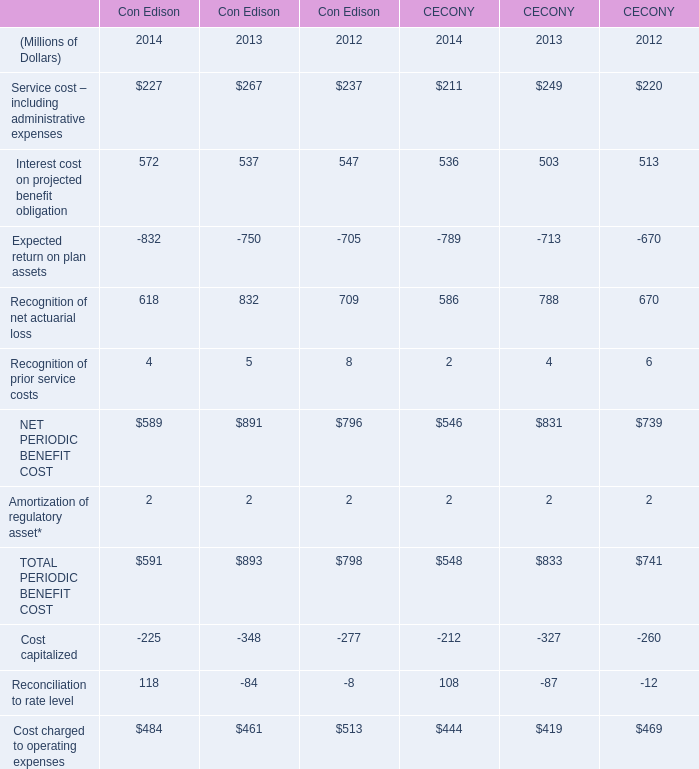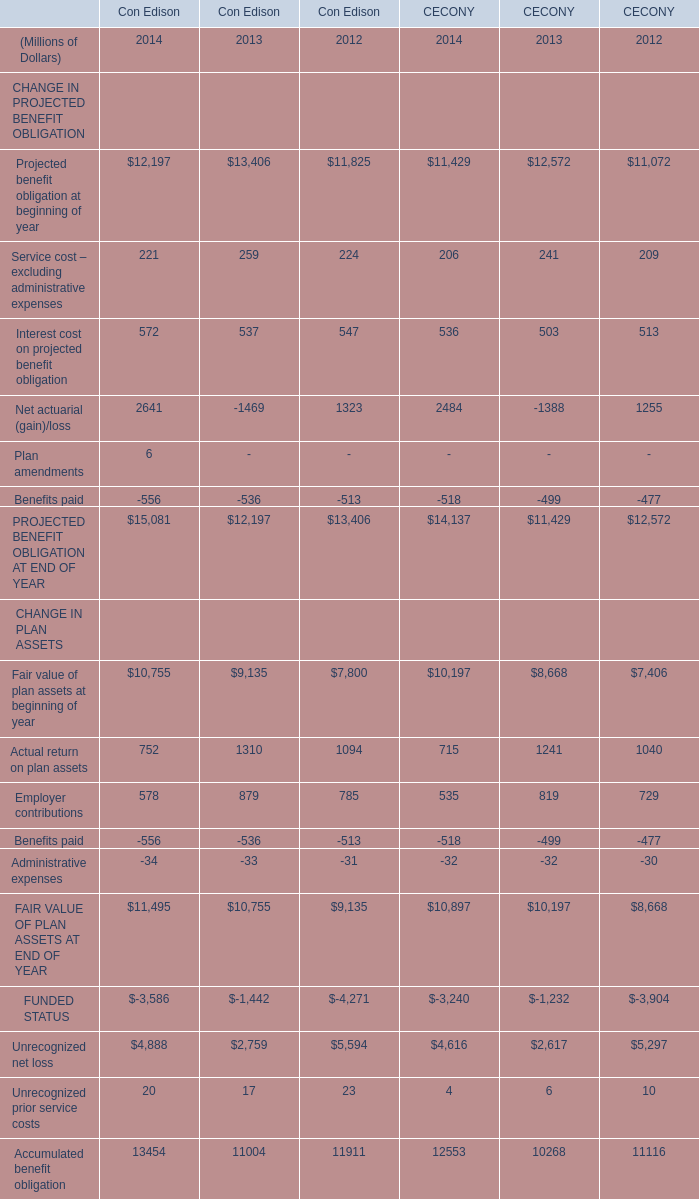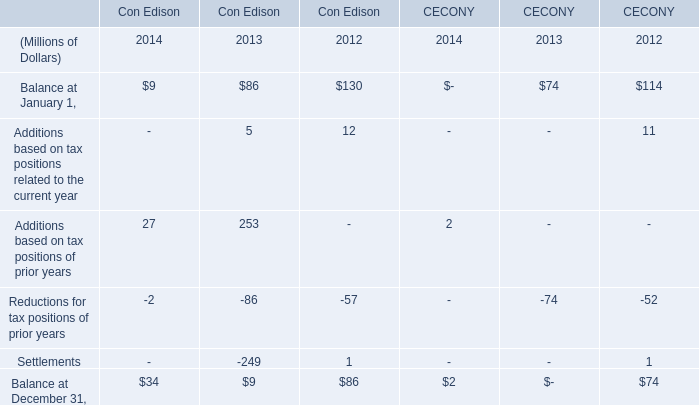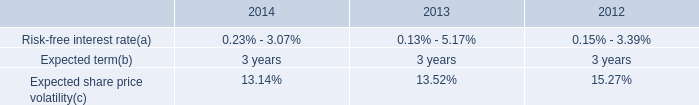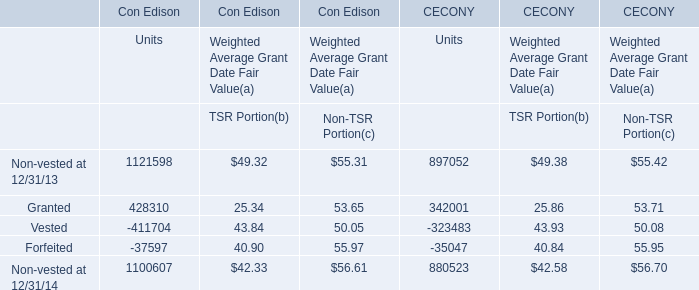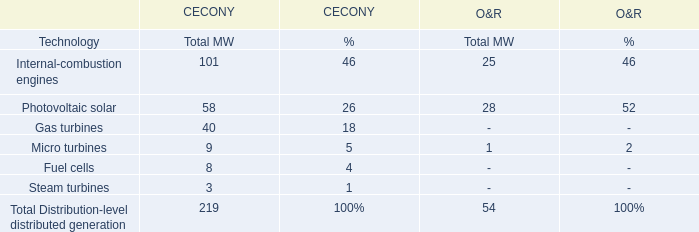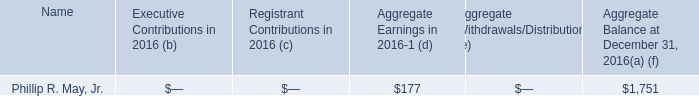what's the total amount of Projected benefit obligation at beginning of year of CECONY 2014, and Forfeited of Con Edison Units ? 
Computations: (11429.0 + 37597.0)
Answer: 49026.0. 